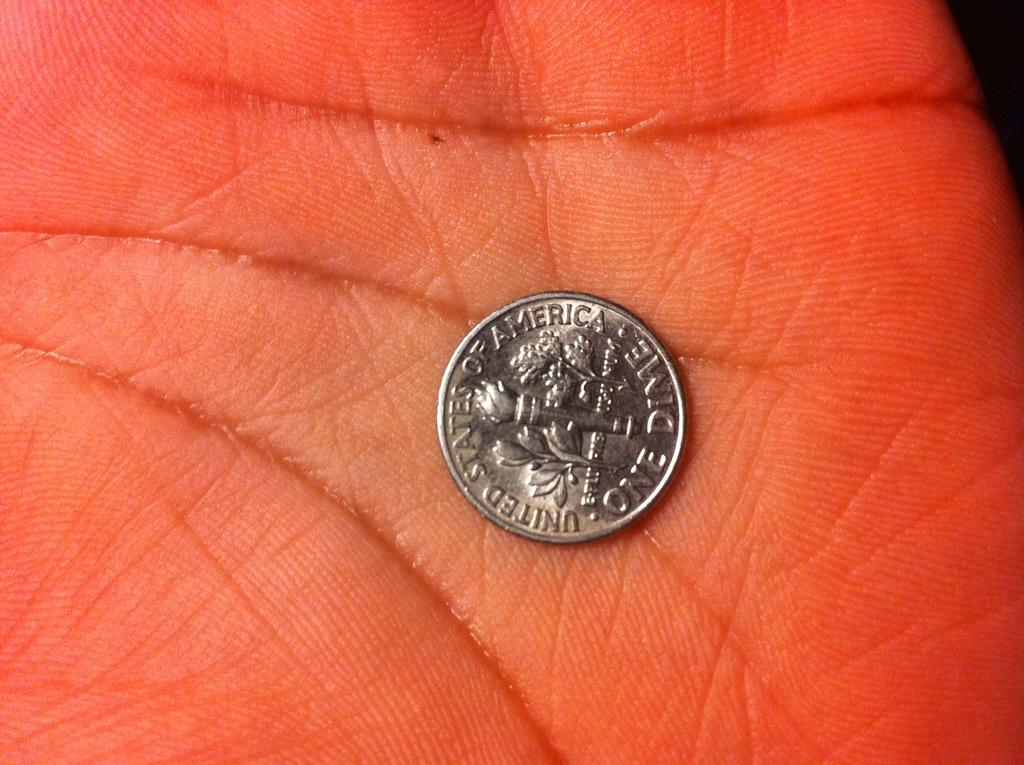<image>
Offer a succinct explanation of the picture presented. A United States of America one dime coin sits in the palm of a hand. 